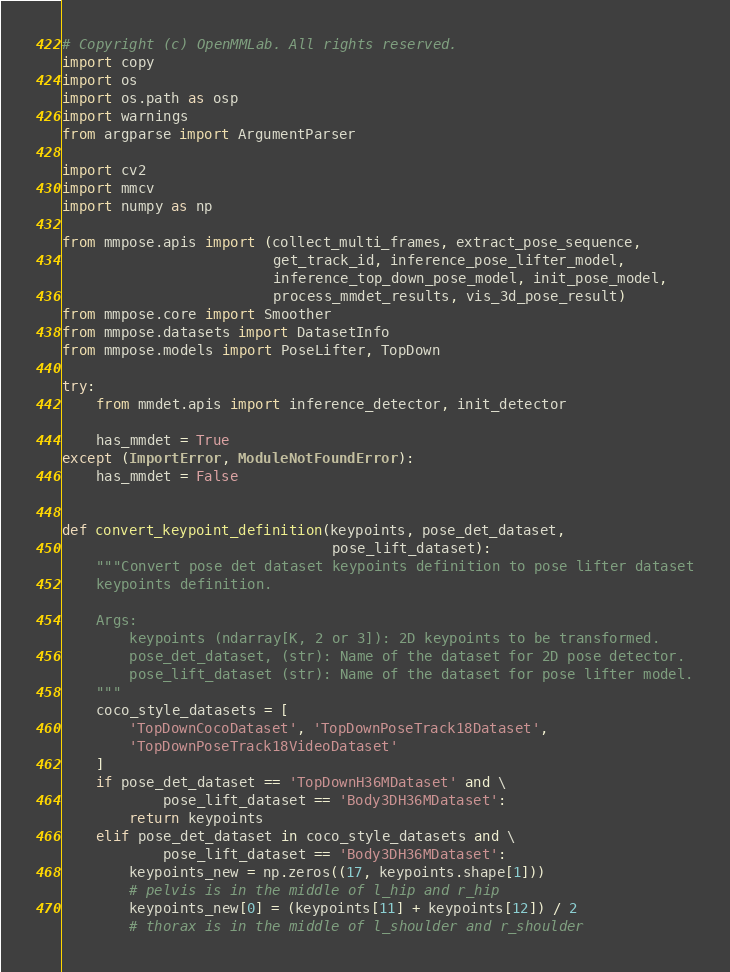Convert code to text. <code><loc_0><loc_0><loc_500><loc_500><_Python_># Copyright (c) OpenMMLab. All rights reserved.
import copy
import os
import os.path as osp
import warnings
from argparse import ArgumentParser

import cv2
import mmcv
import numpy as np

from mmpose.apis import (collect_multi_frames, extract_pose_sequence,
                         get_track_id, inference_pose_lifter_model,
                         inference_top_down_pose_model, init_pose_model,
                         process_mmdet_results, vis_3d_pose_result)
from mmpose.core import Smoother
from mmpose.datasets import DatasetInfo
from mmpose.models import PoseLifter, TopDown

try:
    from mmdet.apis import inference_detector, init_detector

    has_mmdet = True
except (ImportError, ModuleNotFoundError):
    has_mmdet = False


def convert_keypoint_definition(keypoints, pose_det_dataset,
                                pose_lift_dataset):
    """Convert pose det dataset keypoints definition to pose lifter dataset
    keypoints definition.

    Args:
        keypoints (ndarray[K, 2 or 3]): 2D keypoints to be transformed.
        pose_det_dataset, (str): Name of the dataset for 2D pose detector.
        pose_lift_dataset (str): Name of the dataset for pose lifter model.
    """
    coco_style_datasets = [
        'TopDownCocoDataset', 'TopDownPoseTrack18Dataset',
        'TopDownPoseTrack18VideoDataset'
    ]
    if pose_det_dataset == 'TopDownH36MDataset' and \
            pose_lift_dataset == 'Body3DH36MDataset':
        return keypoints
    elif pose_det_dataset in coco_style_datasets and \
            pose_lift_dataset == 'Body3DH36MDataset':
        keypoints_new = np.zeros((17, keypoints.shape[1]))
        # pelvis is in the middle of l_hip and r_hip
        keypoints_new[0] = (keypoints[11] + keypoints[12]) / 2
        # thorax is in the middle of l_shoulder and r_shoulder</code> 